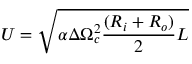Convert formula to latex. <formula><loc_0><loc_0><loc_500><loc_500>U = \sqrt { \alpha \Delta \Omega _ { c } ^ { 2 } \frac { ( R _ { i } + R _ { o } ) } { 2 } L }</formula> 